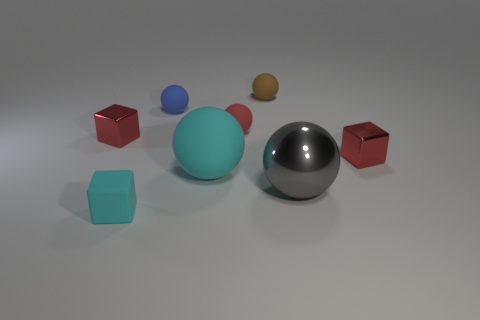Subtract all red blocks. How many blocks are left? 1 Subtract all cyan cubes. How many cubes are left? 2 Subtract all spheres. How many objects are left? 3 Subtract 2 blocks. How many blocks are left? 1 Add 5 tiny red blocks. How many tiny red blocks are left? 7 Add 3 red matte objects. How many red matte objects exist? 4 Add 2 red spheres. How many objects exist? 10 Subtract 0 brown cylinders. How many objects are left? 8 Subtract all cyan spheres. Subtract all purple cylinders. How many spheres are left? 4 Subtract all purple balls. How many cyan cubes are left? 1 